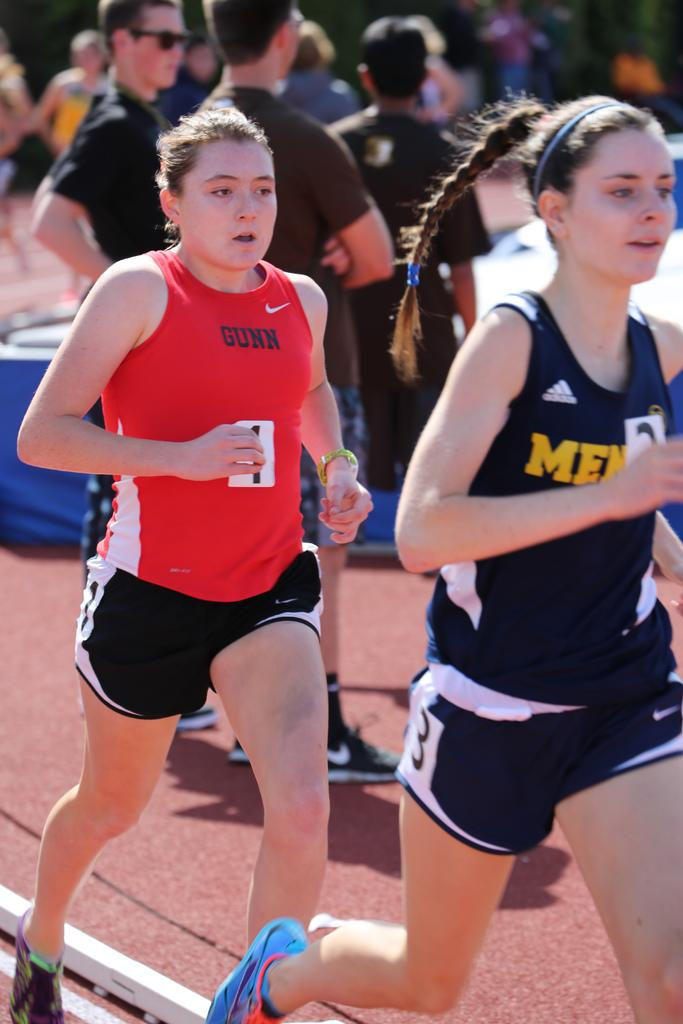<image>
Write a terse but informative summary of the picture. a girl running with the word Gunn on her shirt 